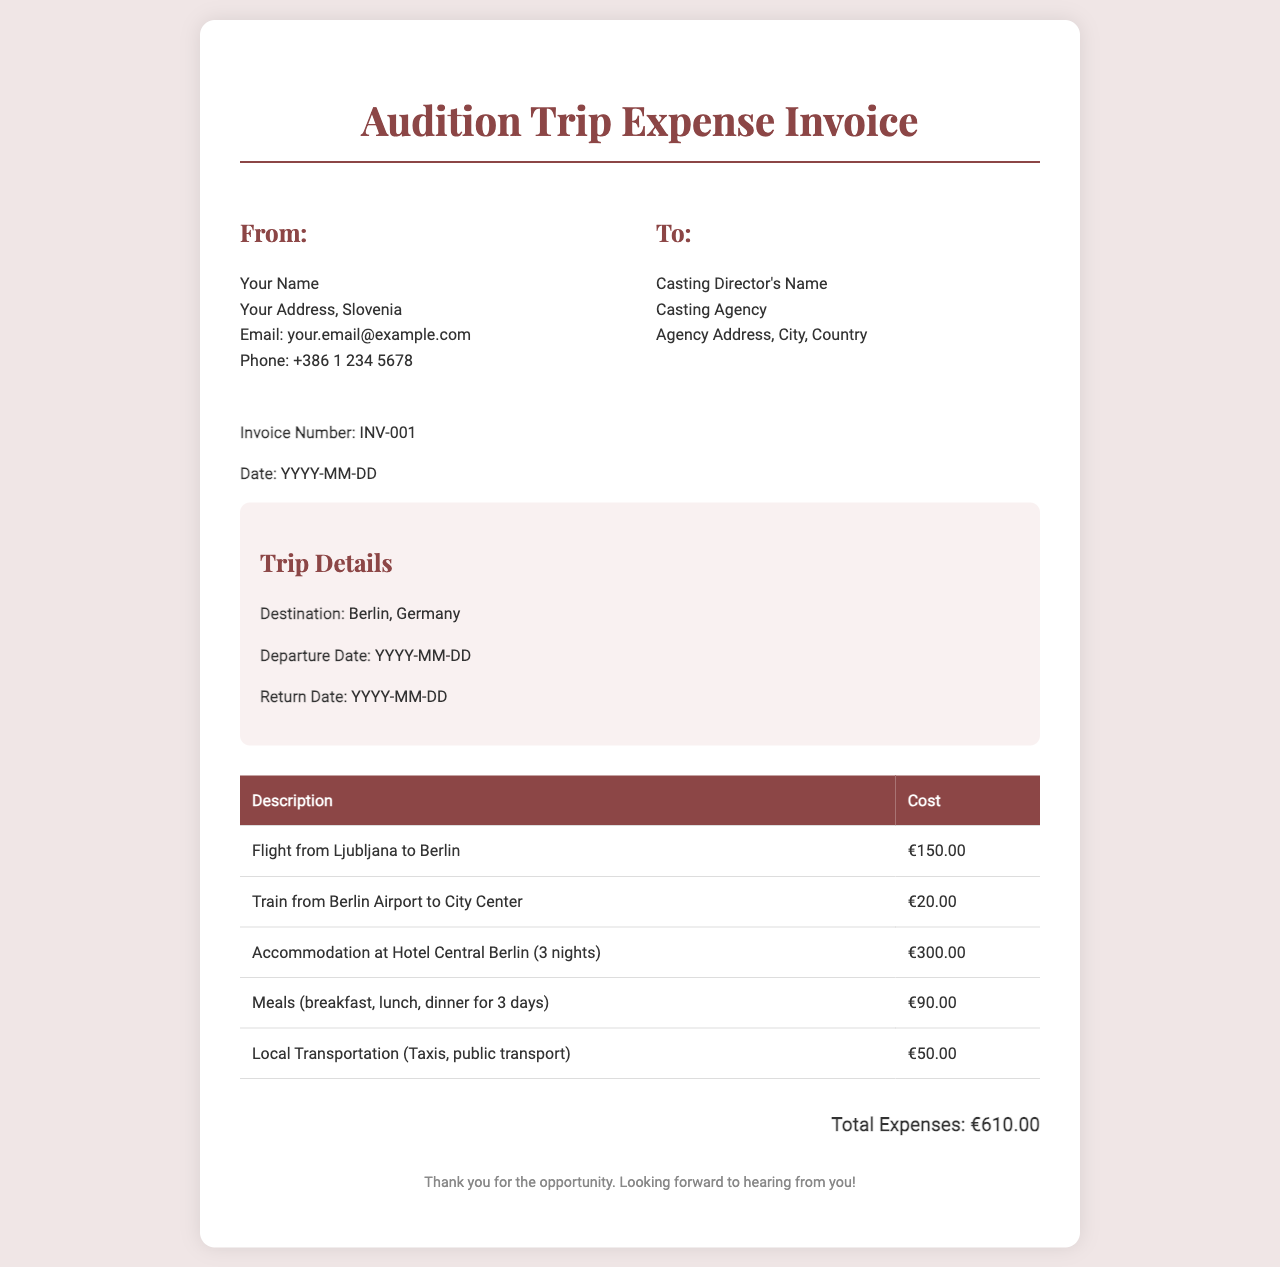What is the invoice number? The invoice number is listed in the document as a specific identifier for the invoice.
Answer: INV-001 What is the total expenses amount? The total expenses are calculated as the sum of all itemized costs in the invoice.
Answer: €610.00 What city was the trip destination? The destination city for the audition trip is explicitly mentioned in the document.
Answer: Berlin How many nights was accommodation booked for? The invoice specifies the duration of accommodation for a clear understanding of the stay.
Answer: 3 nights What was the cost of the flight? The flight cost is directly stated in the expense table of the document.
Answer: €150.00 What meals are included in the expenses? The types of meals covered during the trip are stated in the invoiced expenses section.
Answer: breakfast, lunch, dinner What is the departure date? The document presents the intended date of departure for the trip, which is part of the trip details.
Answer: YYYY-MM-DD What type of document is this? This document's structure and content identify it as a specific type of financial record.
Answer: Invoice How much was spent on local transportation? The amount allocated for local transportation is mentioned in the expense detail section of the document.
Answer: €50.00 